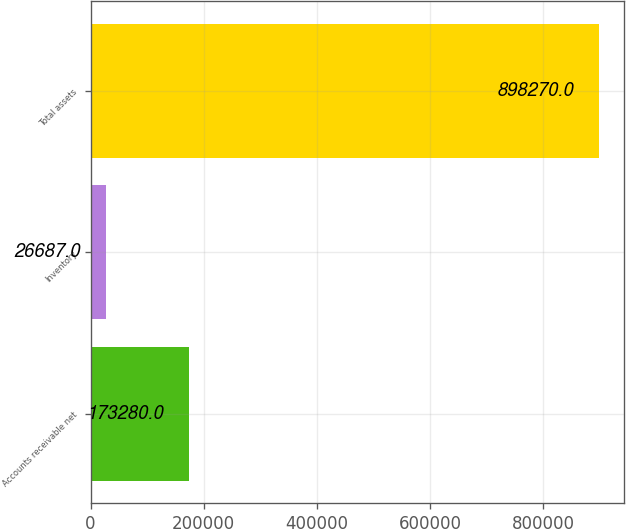<chart> <loc_0><loc_0><loc_500><loc_500><bar_chart><fcel>Accounts receivable net<fcel>Inventory<fcel>Total assets<nl><fcel>173280<fcel>26687<fcel>898270<nl></chart> 